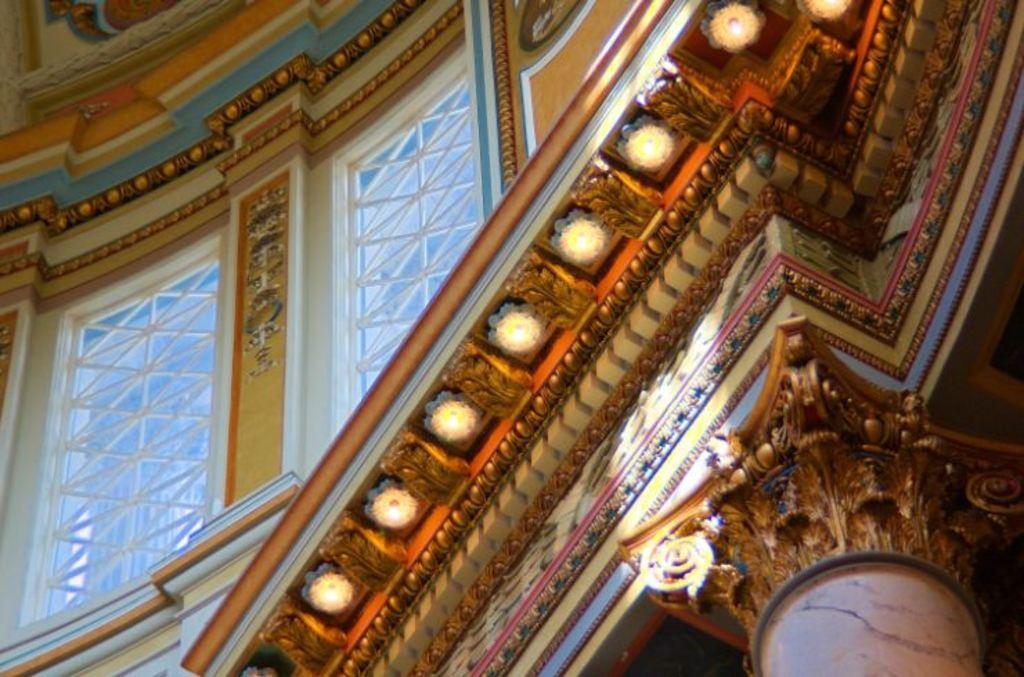Can you describe this image briefly? This image is taken in a Cathedral. In this image there is a wall with windows and there are a few sculptures, carvings and lamps. 